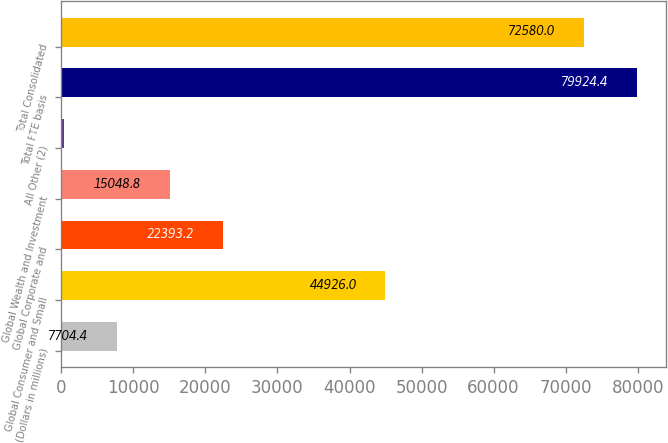Convert chart to OTSL. <chart><loc_0><loc_0><loc_500><loc_500><bar_chart><fcel>(Dollars in millions)<fcel>Global Consumer and Small<fcel>Global Corporate and<fcel>Global Wealth and Investment<fcel>All Other (2)<fcel>Total FTE basis<fcel>Total Consolidated<nl><fcel>7704.4<fcel>44926<fcel>22393.2<fcel>15048.8<fcel>360<fcel>79924.4<fcel>72580<nl></chart> 